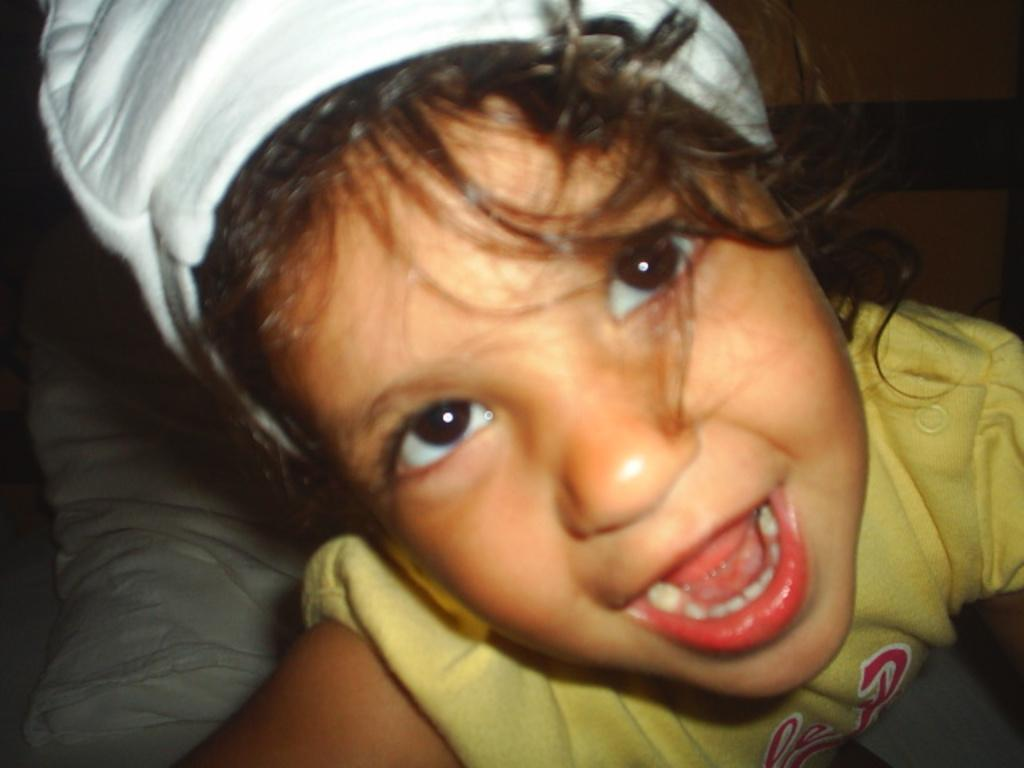What is the main subject of the image? The main subject of the image is a kid. What is the kid wearing on their upper body? The kid is wearing a yellow shirt. What type of headwear is the kid wearing? The kid is wearing a cap. What object can be seen behind the kid? There is a pillow behind the kid. What type of anger can be seen on the kid's face in the image? There is no indication of anger on the kid's face in the image. Can you describe the zephyr blowing through the room in the image? There is no mention of a zephyr or any wind in the image; it is a still image. 